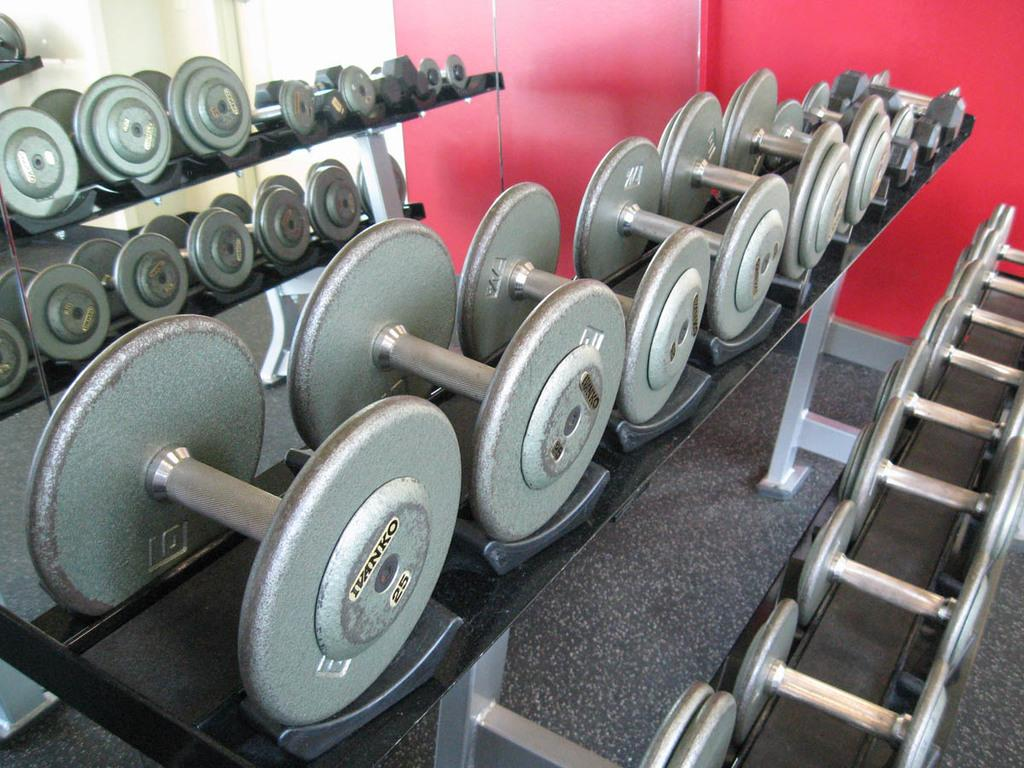What type of equipment is present in the image? There are dumbbells in the image. How are the dumbbells arranged or stored? The dumbbells are on a rack. What is the rack resting on? The rack stands on the floor. What can be seen in the background of the image? There is a wall visible in the background of the image. What type of card game is being played in the image? There is no card game present in the image; it features dumbbells on a rack. What sound can be heard during a thunderstorm in the image? There is no thunderstorm present in the image, so no such sound can be heard. 